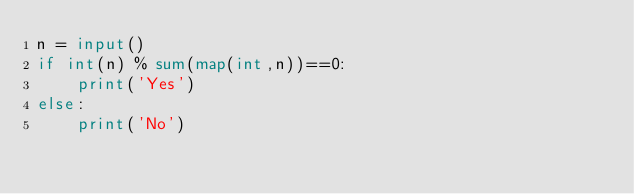<code> <loc_0><loc_0><loc_500><loc_500><_Python_>n = input()
if int(n) % sum(map(int,n))==0:
    print('Yes')
else:
    print('No')
</code> 